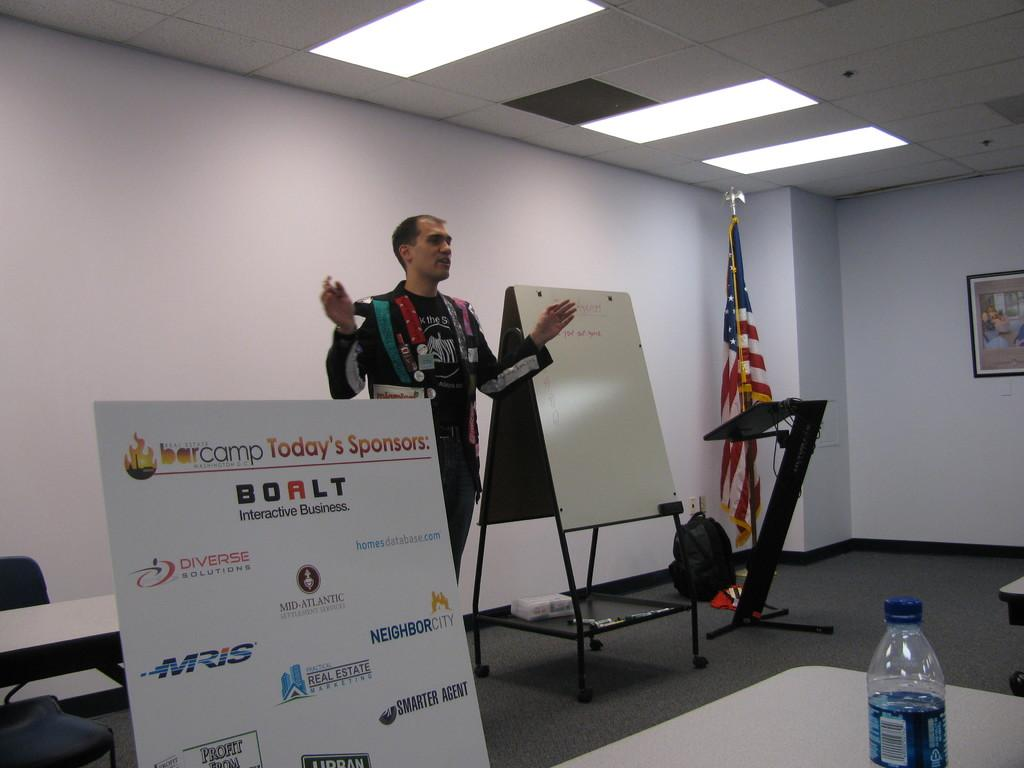What is the main subject of the image? There is a man standing in the image. What object can be seen in the image besides the man? There is a board in the image. Is there any other notable object in the image? Yes, there is a flag in the image. What type of fruit is hanging from the flag in the image? There is no fruit hanging from the flag in the image; it is a flag with no fruit present. 